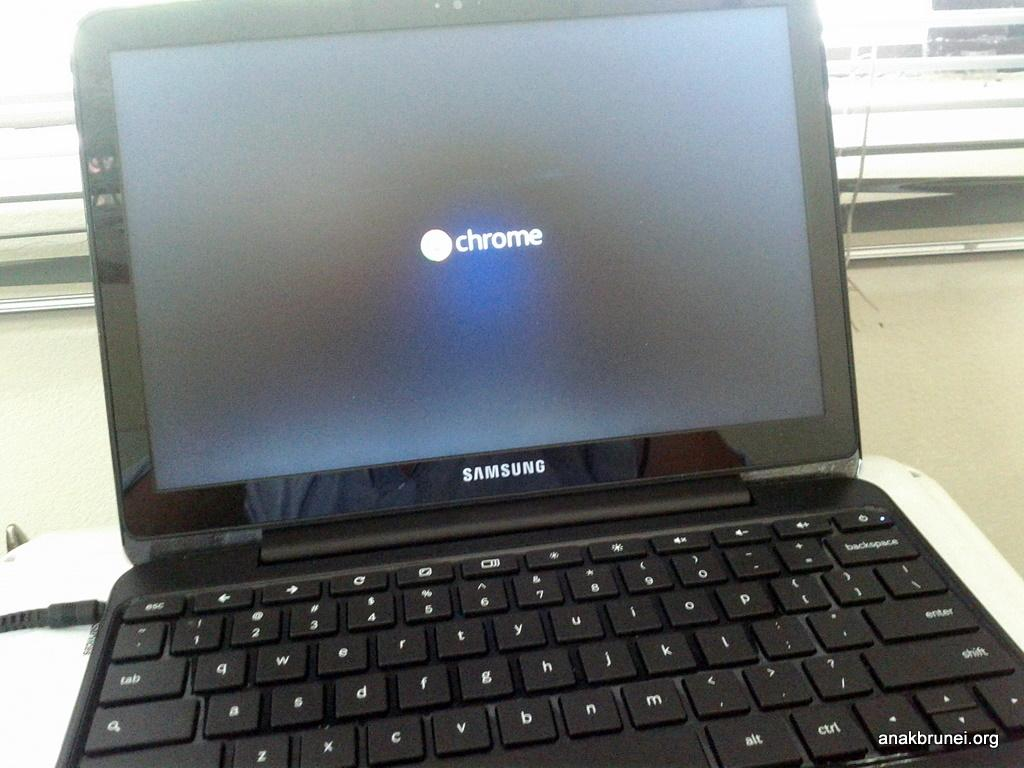<image>
Share a concise interpretation of the image provided. Black Samsung laptop that has a screen saying Chrome. 